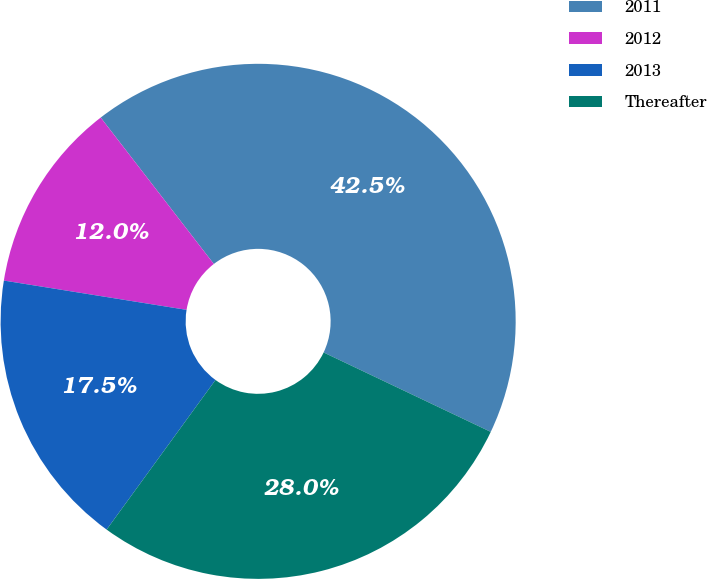Convert chart. <chart><loc_0><loc_0><loc_500><loc_500><pie_chart><fcel>2011<fcel>2012<fcel>2013<fcel>Thereafter<nl><fcel>42.53%<fcel>12.0%<fcel>17.52%<fcel>27.95%<nl></chart> 